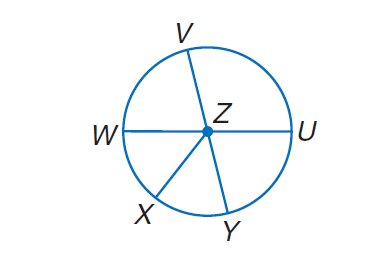Question: In \odot Z, \angle W Z X \cong \angle X Z Y, m \angle V Z U = 4 x, m \angle U Z Y = 2 x + 24, and V Y and W U are diameters. Find m \widehat U Y.
Choices:
A. 14
B. 24
C. 76
D. 104
Answer with the letter. Answer: C Question: In \odot Z, \angle W Z X \cong \angle X Z Y, m \angle V Z U = 4 x, m \angle U Z Y = 2 x + 24, and V Y and W U are diameters. Find m \widehat W X.
Choices:
A. 48
B. 52
C. 90
D. 180
Answer with the letter. Answer: B Question: In \odot Z, \angle W Z X \cong \angle X Z Y, m \angle V Z U = 4 x, m \angle U Z Y = 2 x + 24, and V Y and W U are diameters. Find m \widehat W V.
Choices:
A. 14
B. 24
C. 76
D. 104
Answer with the letter. Answer: C 